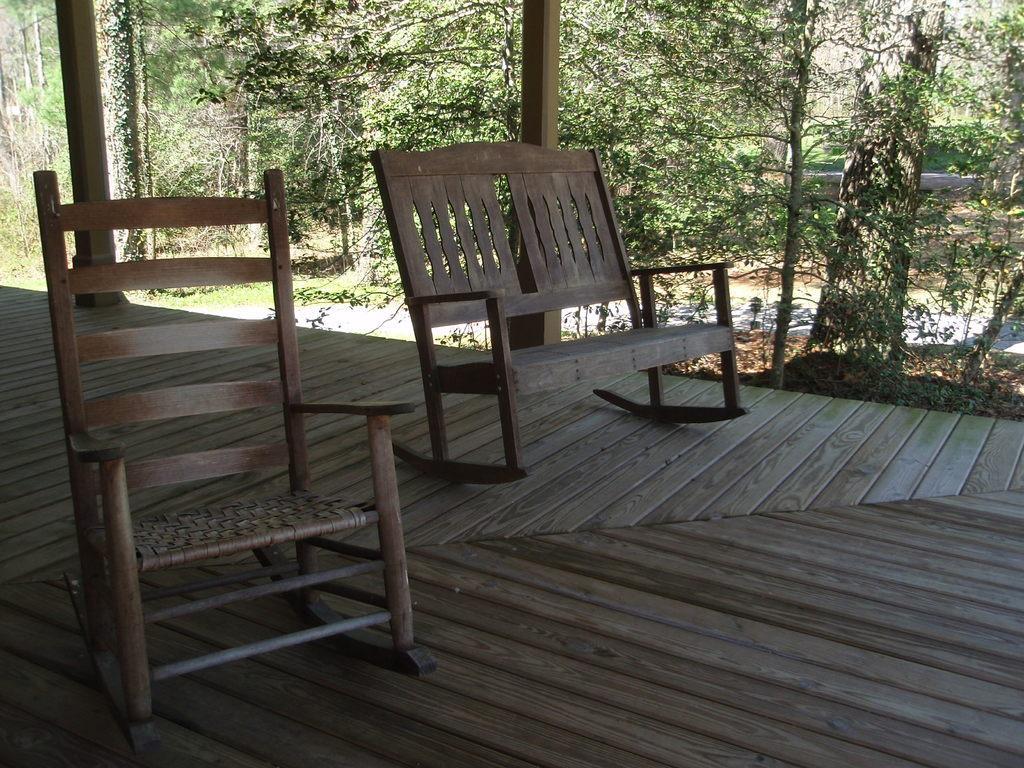Please provide a concise description of this image. This picture shows couple of wooden chairs and we see trees. 